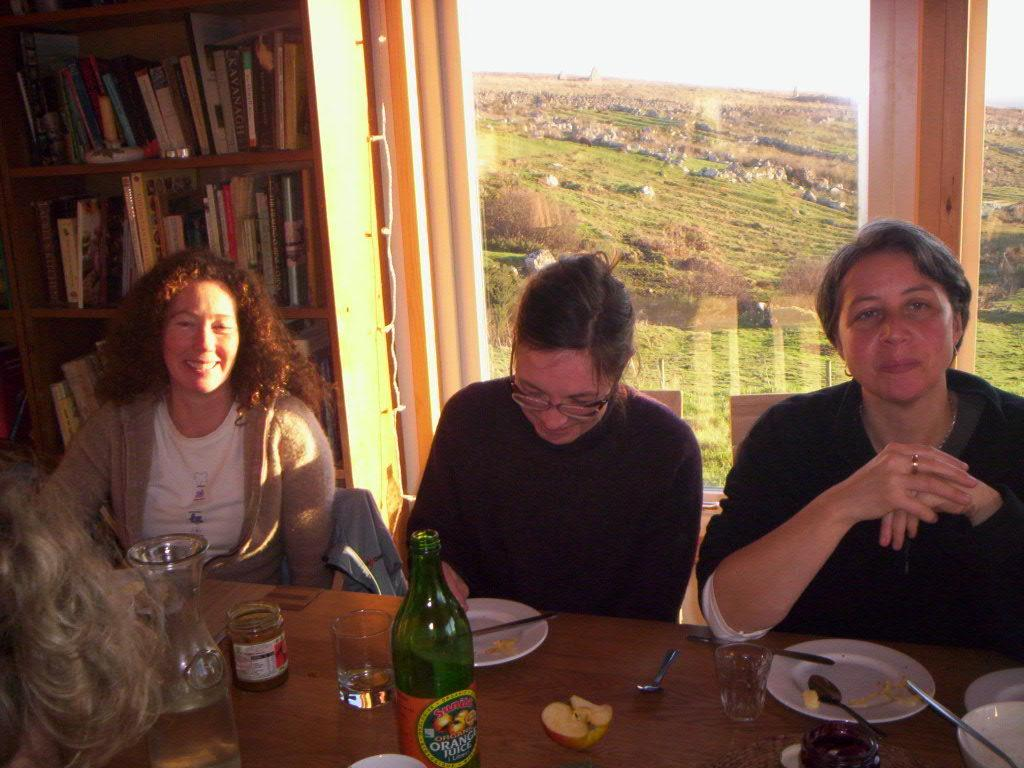How many people are in the image? There are three persons in the image. What are the persons doing in the image? The persons are sitting in front of a table. What can be seen on the table in the image? The table has eatables and drinks on it. What other furniture or fixture is present in the image? There is a book shelf in the image. What can be seen in the background of the image? There is a greenery ground in the background of the image. How many chairs are visible in the image? The provided facts do not mention chairs, so we cannot determine the number of chairs in the image. What type of food is being prepared on the table in the image? The provided facts do not mention any food preparation; the table has eatables and drinks on it, but we cannot determine the specific type of food. 